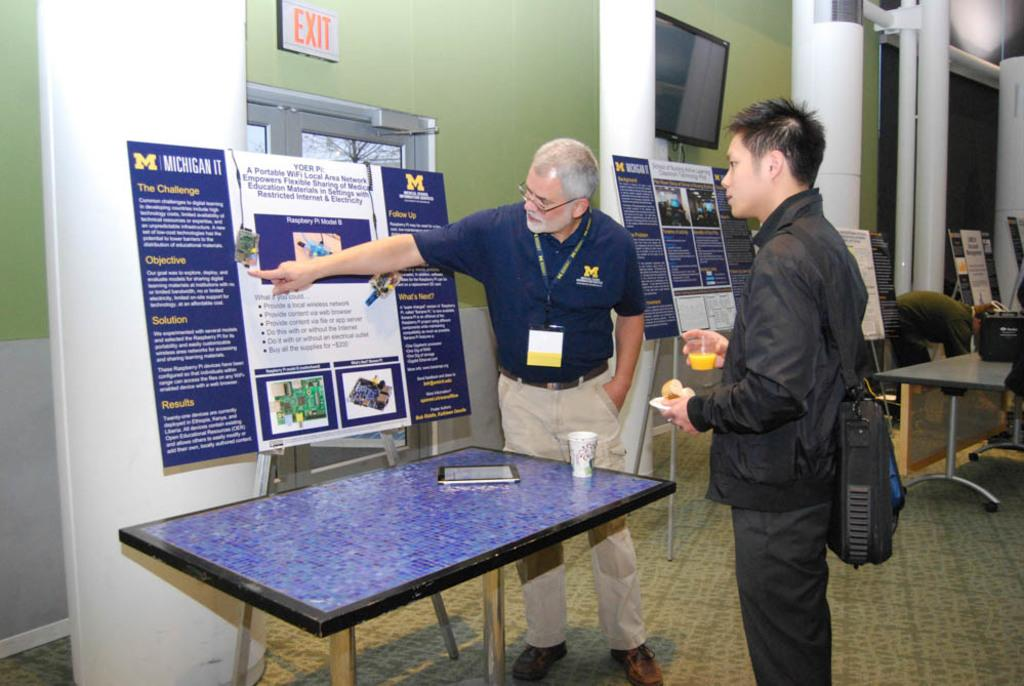What is one of the main structures in the image? There is a wall in the image. Who or what can be seen in front of the wall? There are people standing in the image. What piece of furniture is present in the image? There is a table in the image. What electronic device is on the table? There is a tablet on the table. What type of beverage container is on the table? There is a glass on the table. What additional item is hanging in the image? There is a banner in the image. What type of soda is being poured into the glass in the image? There is no soda present in the image; only a glass is visible on the table. What is the angle at which the people are standing in the image? The angle at which the people are standing cannot be determined from the image, as it only provides a two-dimensional representation. 